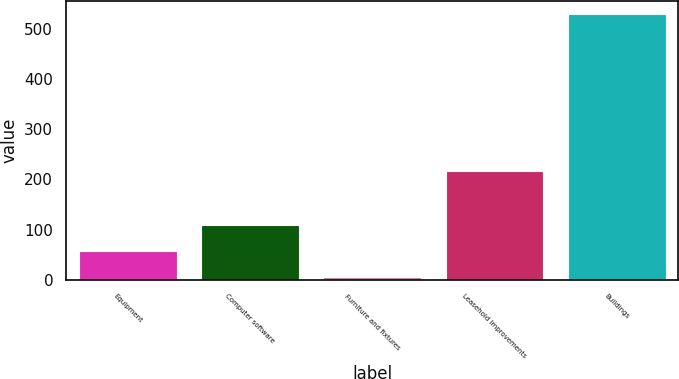Convert chart to OTSL. <chart><loc_0><loc_0><loc_500><loc_500><bar_chart><fcel>Equipment<fcel>Computer software<fcel>Furniture and fixtures<fcel>Leasehold improvements<fcel>Buildings<nl><fcel>57.5<fcel>110<fcel>5<fcel>216<fcel>530<nl></chart> 